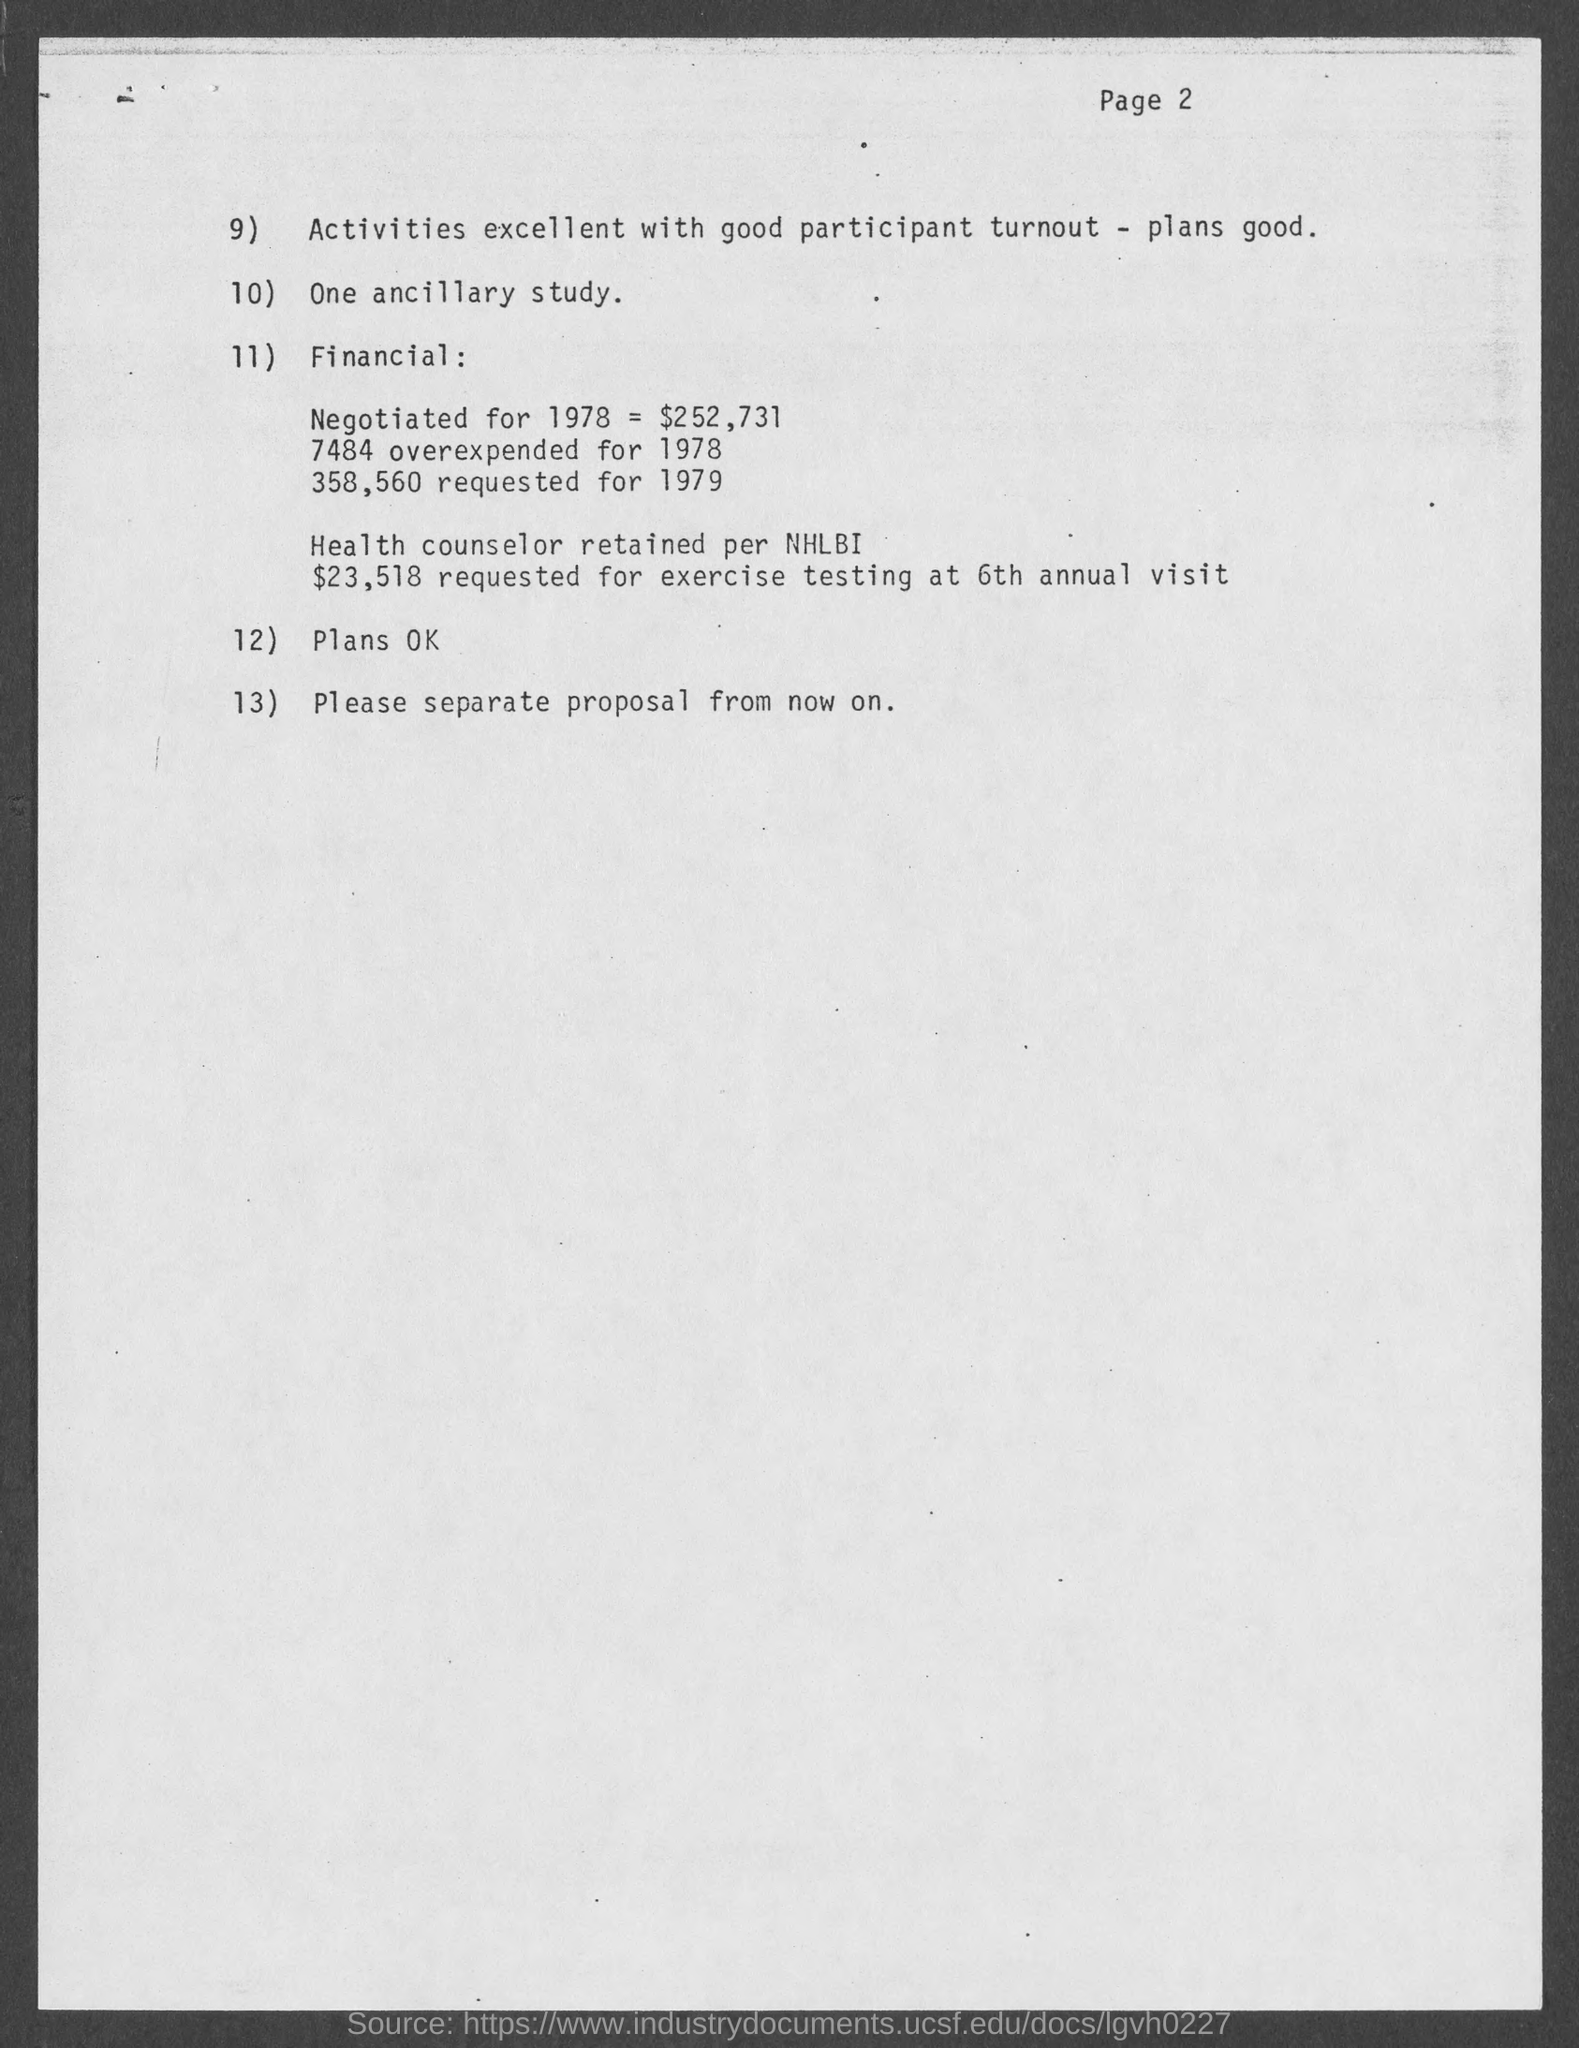what is the page number at top of the page?
 2 